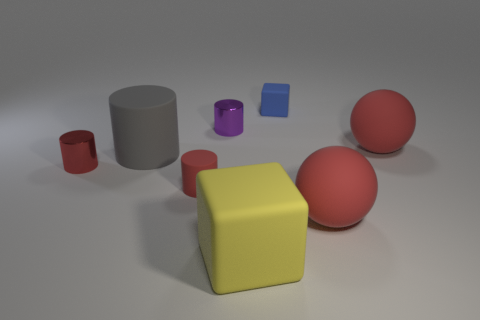Subtract all tiny purple cylinders. How many cylinders are left? 3 Subtract 1 blocks. How many blocks are left? 1 Subtract all gray balls. Subtract all blue blocks. How many balls are left? 2 Add 8 large red cubes. How many large red cubes exist? 8 Add 2 red rubber spheres. How many objects exist? 10 Subtract all gray cylinders. How many cylinders are left? 3 Subtract 0 gray spheres. How many objects are left? 8 Subtract all cubes. How many objects are left? 6 Subtract all red cylinders. How many yellow balls are left? 0 Subtract all rubber cylinders. Subtract all small blocks. How many objects are left? 5 